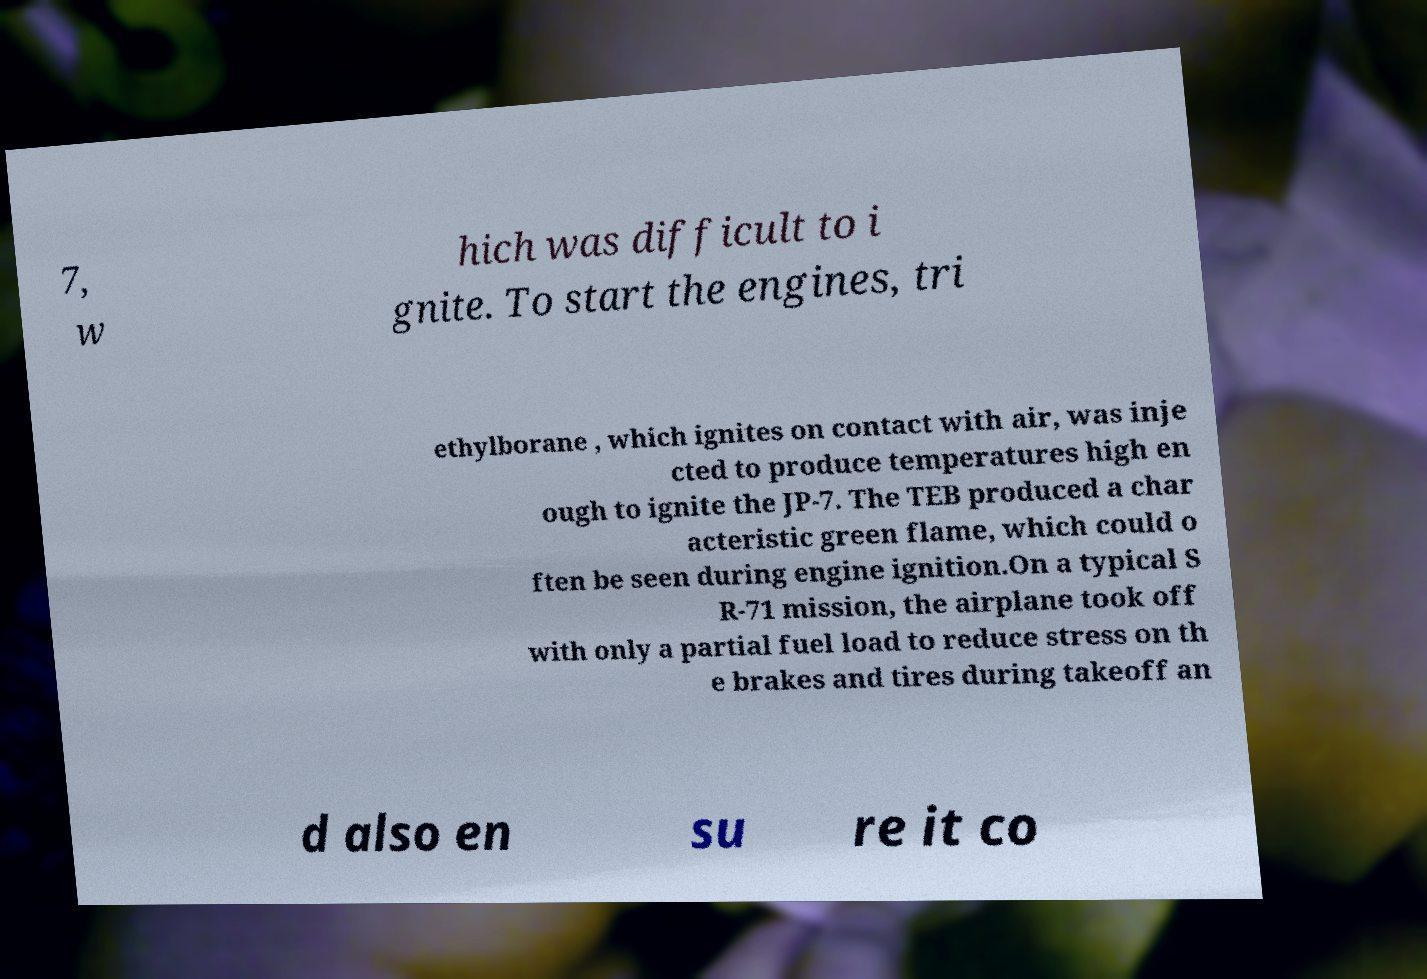Could you assist in decoding the text presented in this image and type it out clearly? 7, w hich was difficult to i gnite. To start the engines, tri ethylborane , which ignites on contact with air, was inje cted to produce temperatures high en ough to ignite the JP-7. The TEB produced a char acteristic green flame, which could o ften be seen during engine ignition.On a typical S R-71 mission, the airplane took off with only a partial fuel load to reduce stress on th e brakes and tires during takeoff an d also en su re it co 